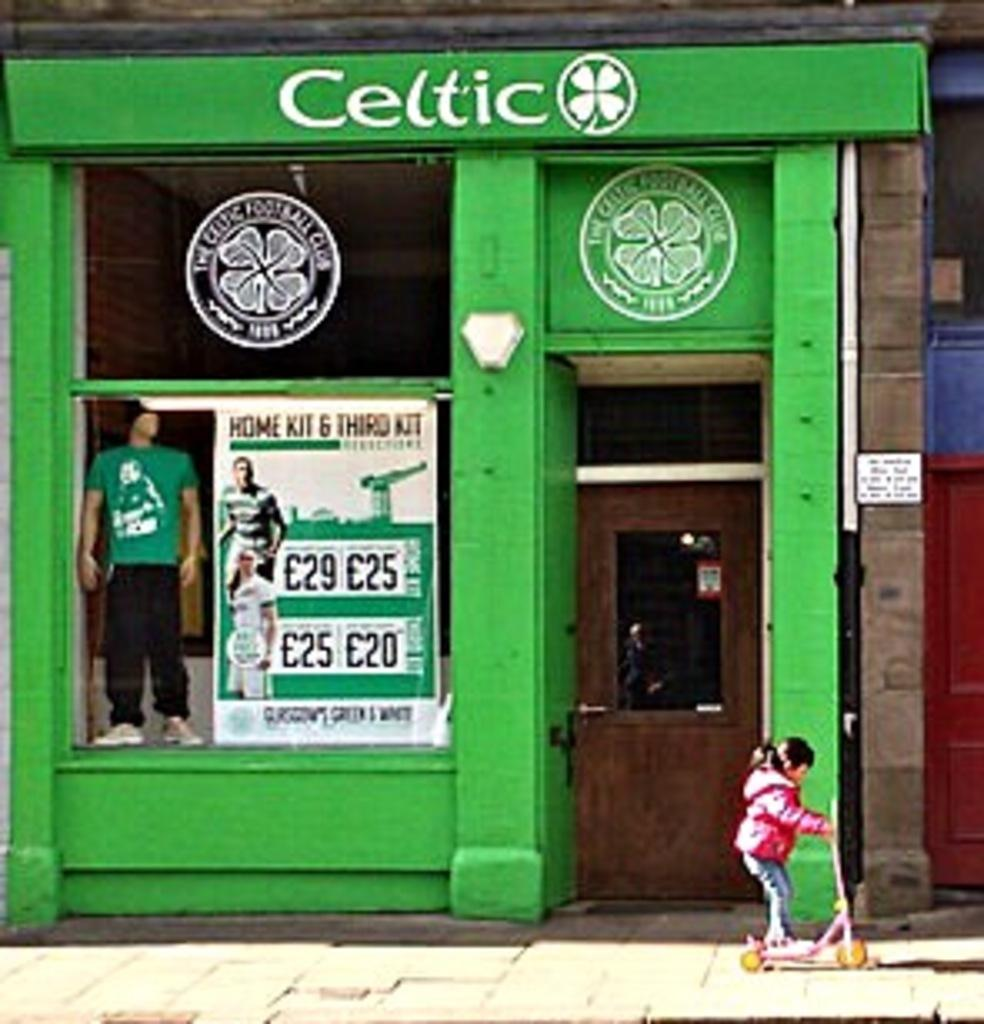<image>
Give a short and clear explanation of the subsequent image. A little girl is riding her scooter in front of a clothing store called celtic with a four leaf clover as its logo. 